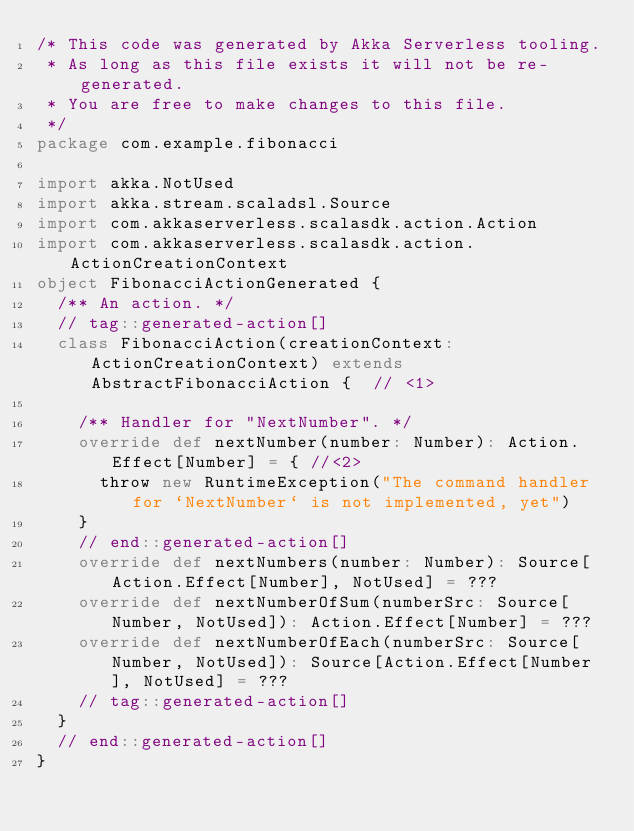Convert code to text. <code><loc_0><loc_0><loc_500><loc_500><_Scala_>/* This code was generated by Akka Serverless tooling.
 * As long as this file exists it will not be re-generated.
 * You are free to make changes to this file.
 */
package com.example.fibonacci

import akka.NotUsed
import akka.stream.scaladsl.Source
import com.akkaserverless.scalasdk.action.Action
import com.akkaserverless.scalasdk.action.ActionCreationContext
object FibonacciActionGenerated {
  /** An action. */
  // tag::generated-action[]
  class FibonacciAction(creationContext: ActionCreationContext) extends AbstractFibonacciAction {  // <1>

    /** Handler for "NextNumber". */
    override def nextNumber(number: Number): Action.Effect[Number] = { //<2>
      throw new RuntimeException("The command handler for `NextNumber` is not implemented, yet")
    }
    // end::generated-action[]
    override def nextNumbers(number: Number): Source[Action.Effect[Number], NotUsed] = ???
    override def nextNumberOfSum(numberSrc: Source[Number, NotUsed]): Action.Effect[Number] = ???
    override def nextNumberOfEach(numberSrc: Source[Number, NotUsed]): Source[Action.Effect[Number], NotUsed] = ???
    // tag::generated-action[]
  }
  // end::generated-action[]
}</code> 